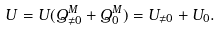<formula> <loc_0><loc_0><loc_500><loc_500>U = U ( Q ^ { M } _ { \neq 0 } + Q ^ { M } _ { 0 } ) = U _ { \neq 0 } + U _ { 0 } .</formula> 